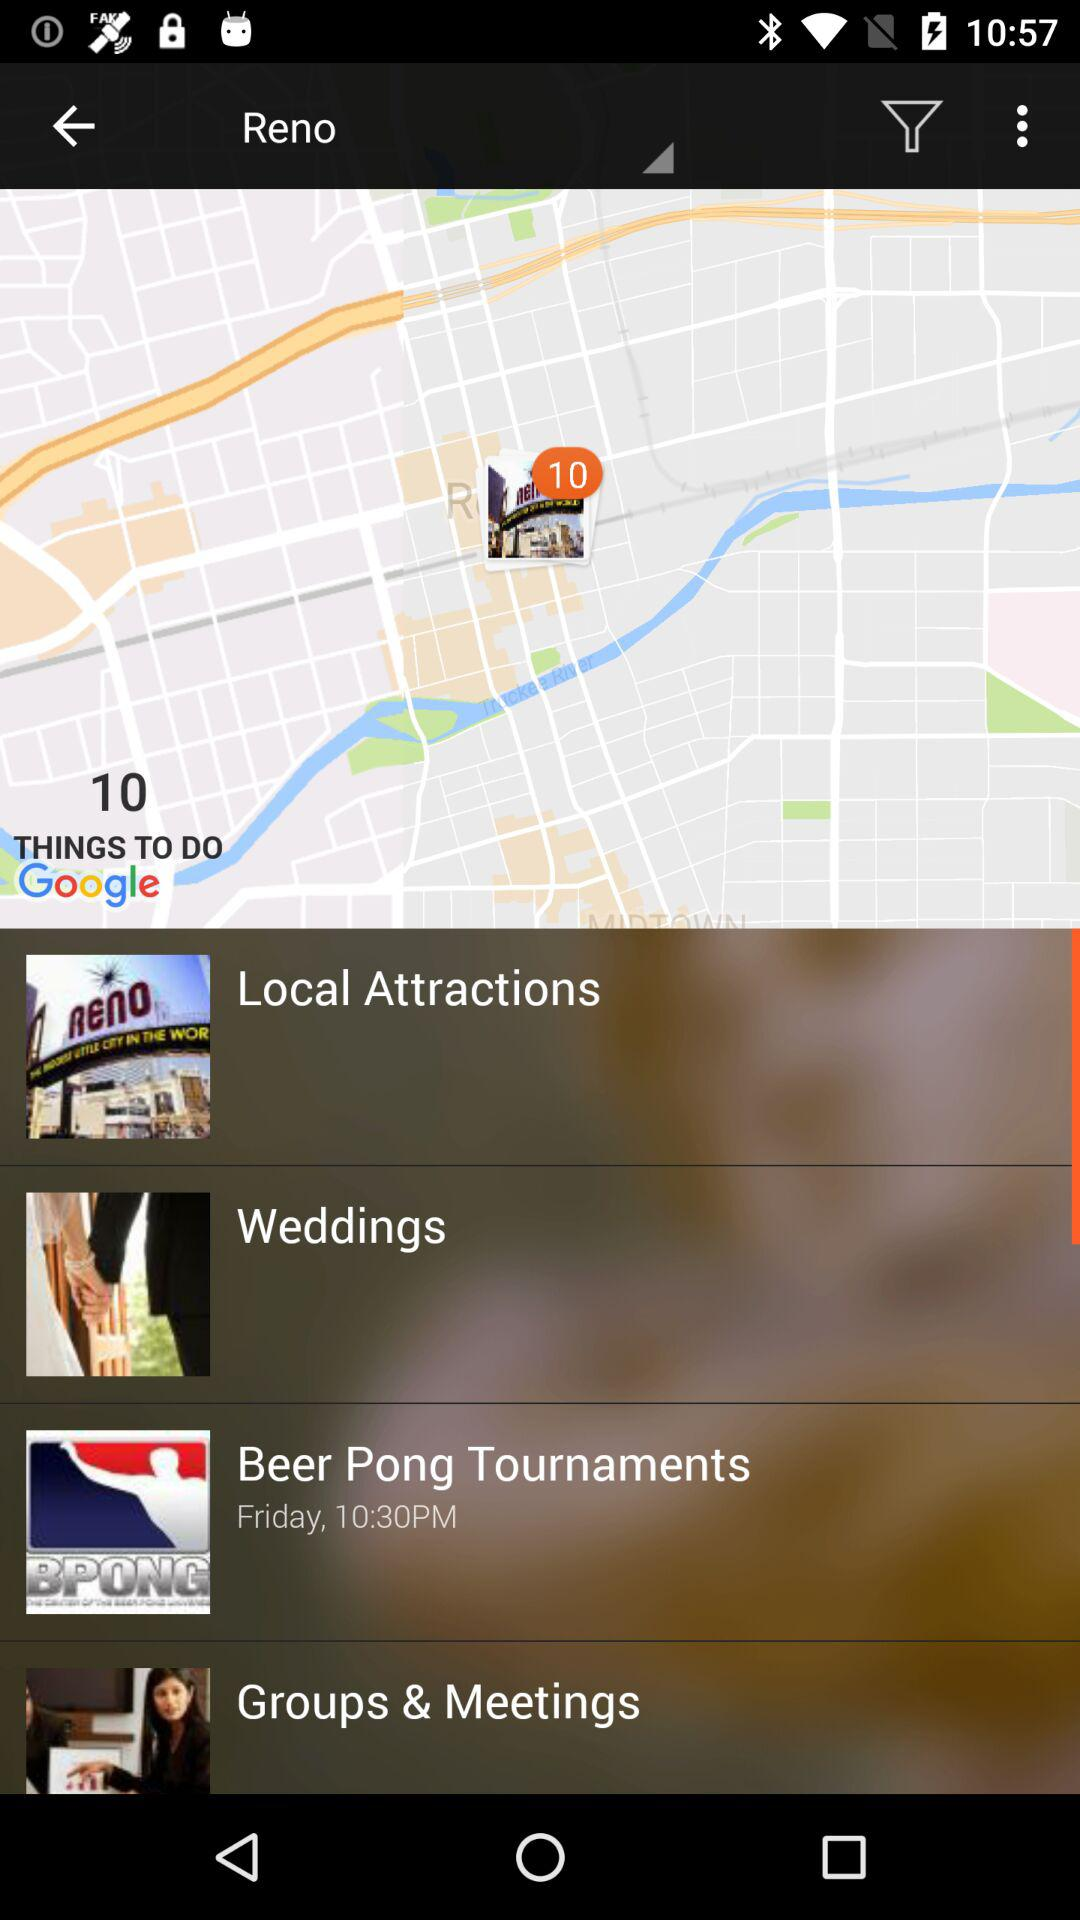What is the tournament day and time? The tournament day and time are Friday and 10:30 PM, respectively. 